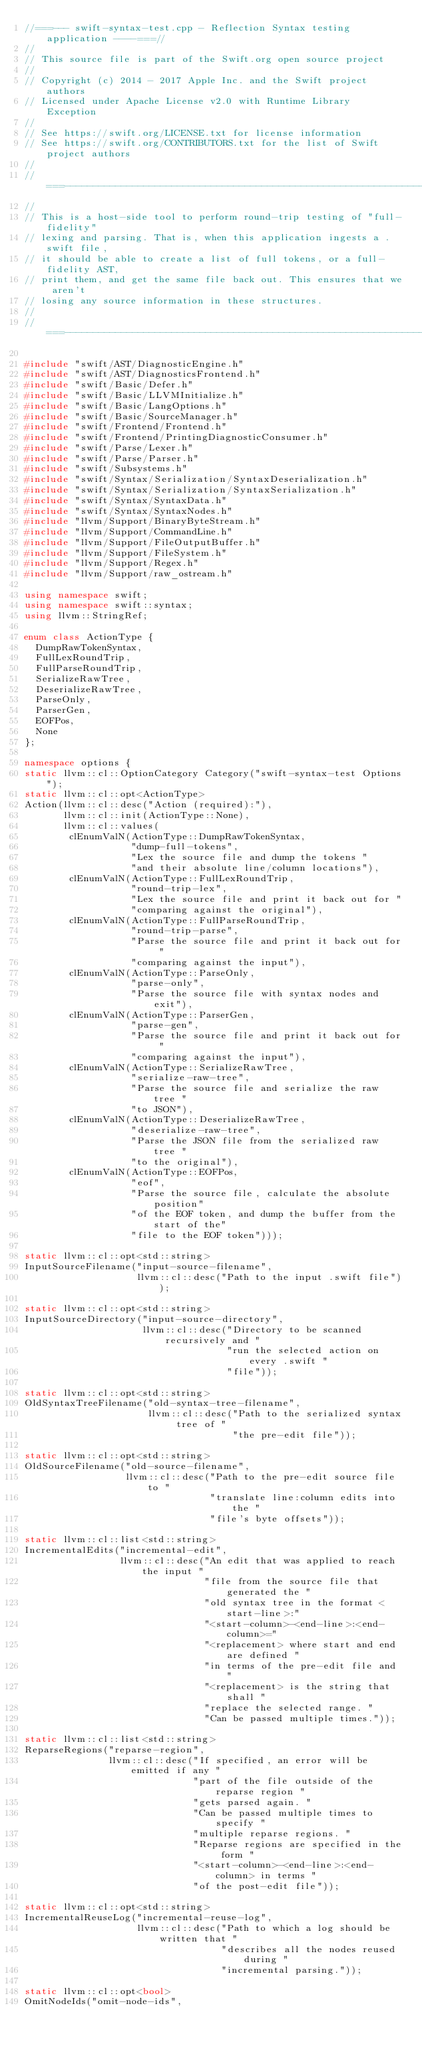<code> <loc_0><loc_0><loc_500><loc_500><_C++_>//===--- swift-syntax-test.cpp - Reflection Syntax testing application ----===//
//
// This source file is part of the Swift.org open source project
//
// Copyright (c) 2014 - 2017 Apple Inc. and the Swift project authors
// Licensed under Apache License v2.0 with Runtime Library Exception
//
// See https://swift.org/LICENSE.txt for license information
// See https://swift.org/CONTRIBUTORS.txt for the list of Swift project authors
//
//===----------------------------------------------------------------------===//
//
// This is a host-side tool to perform round-trip testing of "full-fidelity"
// lexing and parsing. That is, when this application ingests a .swift file,
// it should be able to create a list of full tokens, or a full-fidelity AST,
// print them, and get the same file back out. This ensures that we aren't
// losing any source information in these structures.
//
//===----------------------------------------------------------------------===//

#include "swift/AST/DiagnosticEngine.h"
#include "swift/AST/DiagnosticsFrontend.h"
#include "swift/Basic/Defer.h"
#include "swift/Basic/LLVMInitialize.h"
#include "swift/Basic/LangOptions.h"
#include "swift/Basic/SourceManager.h"
#include "swift/Frontend/Frontend.h"
#include "swift/Frontend/PrintingDiagnosticConsumer.h"
#include "swift/Parse/Lexer.h"
#include "swift/Parse/Parser.h"
#include "swift/Subsystems.h"
#include "swift/Syntax/Serialization/SyntaxDeserialization.h"
#include "swift/Syntax/Serialization/SyntaxSerialization.h"
#include "swift/Syntax/SyntaxData.h"
#include "swift/Syntax/SyntaxNodes.h"
#include "llvm/Support/BinaryByteStream.h"
#include "llvm/Support/CommandLine.h"
#include "llvm/Support/FileOutputBuffer.h"
#include "llvm/Support/FileSystem.h"
#include "llvm/Support/Regex.h"
#include "llvm/Support/raw_ostream.h"

using namespace swift;
using namespace swift::syntax;
using llvm::StringRef;

enum class ActionType {
  DumpRawTokenSyntax,
  FullLexRoundTrip,
  FullParseRoundTrip,
  SerializeRawTree,
  DeserializeRawTree,
  ParseOnly,
  ParserGen,
  EOFPos,
  None
};

namespace options {
static llvm::cl::OptionCategory Category("swift-syntax-test Options");
static llvm::cl::opt<ActionType>
Action(llvm::cl::desc("Action (required):"),
       llvm::cl::init(ActionType::None),
       llvm::cl::values(
        clEnumValN(ActionType::DumpRawTokenSyntax,
                   "dump-full-tokens",
                   "Lex the source file and dump the tokens "
                   "and their absolute line/column locations"),
        clEnumValN(ActionType::FullLexRoundTrip,
                   "round-trip-lex",
                   "Lex the source file and print it back out for "
                   "comparing against the original"),
        clEnumValN(ActionType::FullParseRoundTrip,
                   "round-trip-parse",
                   "Parse the source file and print it back out for "
                   "comparing against the input"),
        clEnumValN(ActionType::ParseOnly,
                   "parse-only",
                   "Parse the source file with syntax nodes and exit"),
        clEnumValN(ActionType::ParserGen,
                   "parse-gen",
                   "Parse the source file and print it back out for "
                   "comparing against the input"),
        clEnumValN(ActionType::SerializeRawTree,
                   "serialize-raw-tree",
                   "Parse the source file and serialize the raw tree "
                   "to JSON"),
        clEnumValN(ActionType::DeserializeRawTree,
                   "deserialize-raw-tree",
                   "Parse the JSON file from the serialized raw tree "
                   "to the original"),
        clEnumValN(ActionType::EOFPos,
                   "eof",
                   "Parse the source file, calculate the absolute position"
                   "of the EOF token, and dump the buffer from the start of the"
                   "file to the EOF token")));

static llvm::cl::opt<std::string>
InputSourceFilename("input-source-filename",
                    llvm::cl::desc("Path to the input .swift file"));

static llvm::cl::opt<std::string>
InputSourceDirectory("input-source-directory",
                     llvm::cl::desc("Directory to be scanned recursively and "
                                    "run the selected action on every .swift "
                                    "file"));

static llvm::cl::opt<std::string>
OldSyntaxTreeFilename("old-syntax-tree-filename",
                      llvm::cl::desc("Path to the serialized syntax tree of "
                                     "the pre-edit file"));

static llvm::cl::opt<std::string>
OldSourceFilename("old-source-filename",
                  llvm::cl::desc("Path to the pre-edit source file to "
                                 "translate line:column edits into the "
                                 "file's byte offsets"));

static llvm::cl::list<std::string>
IncrementalEdits("incremental-edit",
                 llvm::cl::desc("An edit that was applied to reach the input "
                                "file from the source file that generated the "
                                "old syntax tree in the format <start-line>:"
                                "<start-column>-<end-line>:<end-column>="
                                "<replacement> where start and end are defined "
                                "in terms of the pre-edit file and "
                                "<replacement> is the string that shall "
                                "replace the selected range. "
                                "Can be passed multiple times."));

static llvm::cl::list<std::string>
ReparseRegions("reparse-region",
               llvm::cl::desc("If specified, an error will be emitted if any "
                              "part of the file outside of the reparse region "
                              "gets parsed again. "
                              "Can be passed multiple times to specify "
                              "multiple reparse regions. "
                              "Reparse regions are specified in the form "
                              "<start-column>-<end-line>:<end-column> in terms "
                              "of the post-edit file"));

static llvm::cl::opt<std::string>
IncrementalReuseLog("incremental-reuse-log",
                    llvm::cl::desc("Path to which a log should be written that "
                                   "describes all the nodes reused during "
                                   "incremental parsing."));

static llvm::cl::opt<bool>
OmitNodeIds("omit-node-ids",</code> 